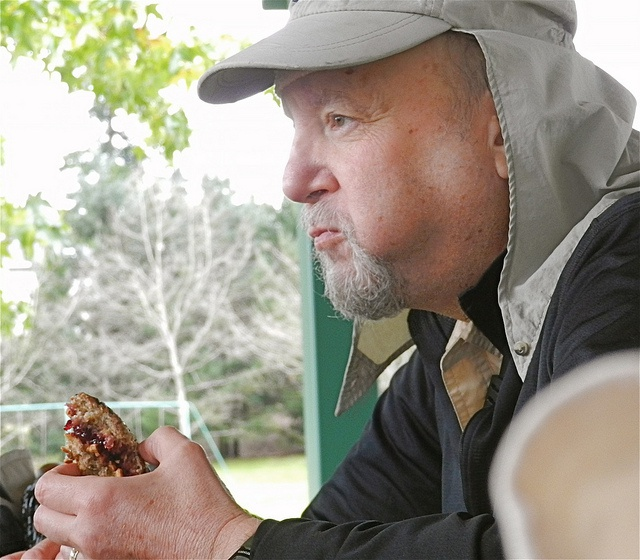Describe the objects in this image and their specific colors. I can see people in khaki, black, darkgray, and gray tones and sandwich in khaki, maroon, gray, and black tones in this image. 